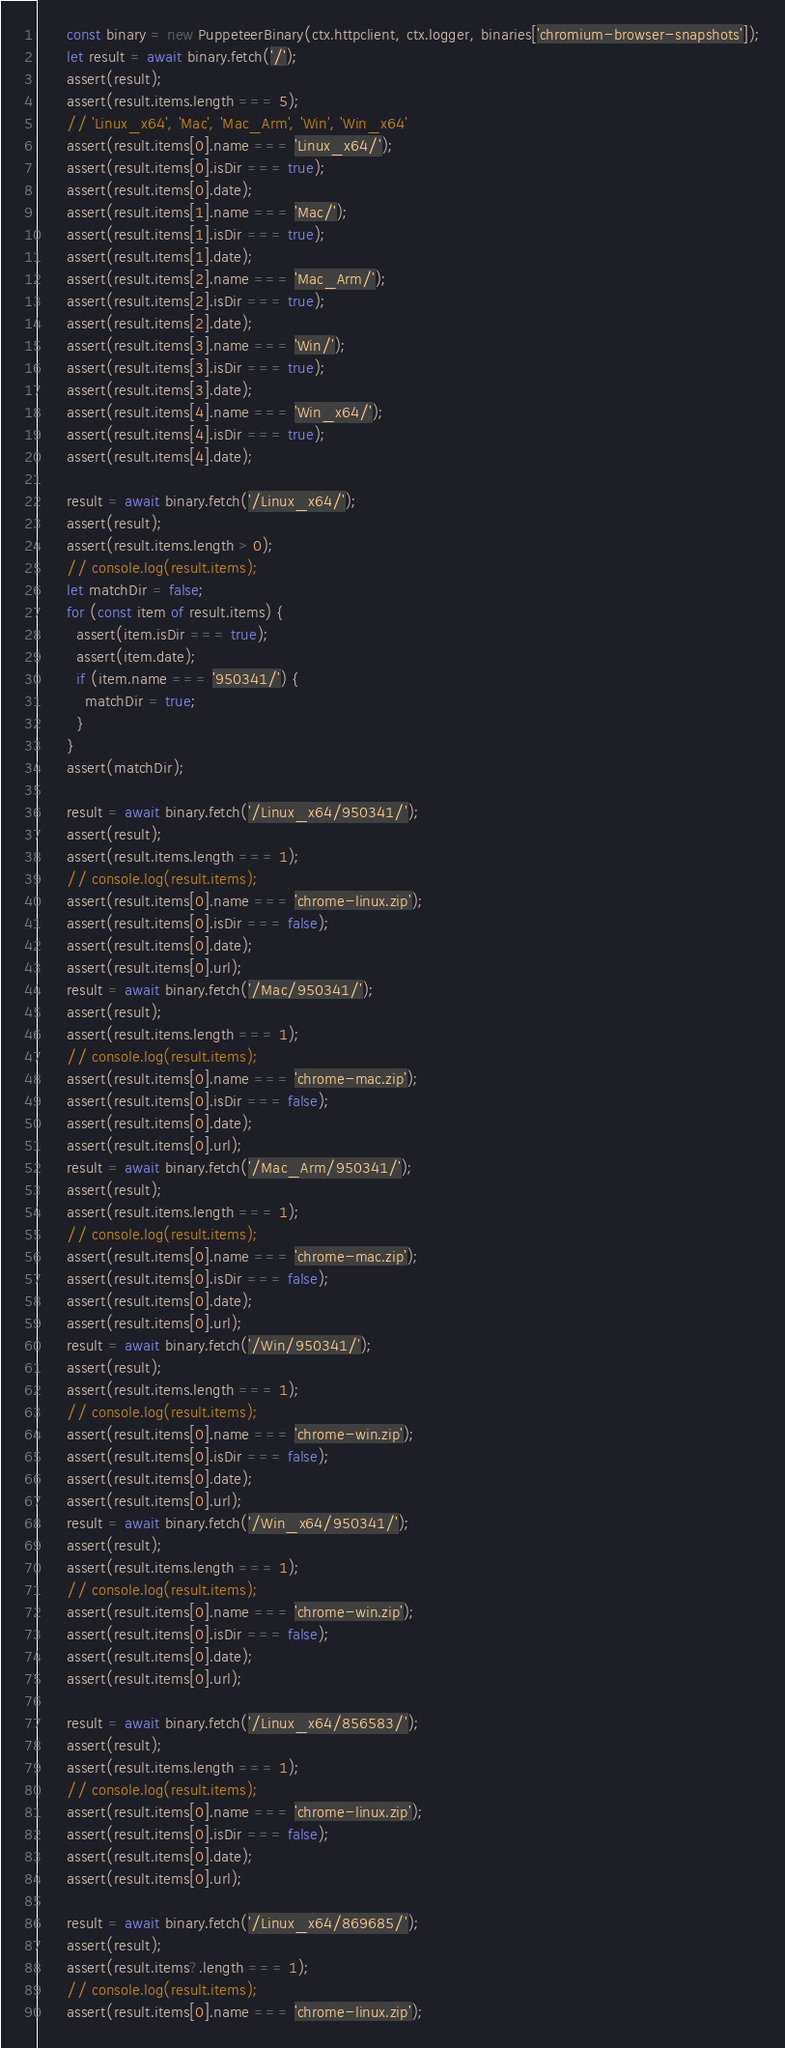Convert code to text. <code><loc_0><loc_0><loc_500><loc_500><_TypeScript_>      const binary = new PuppeteerBinary(ctx.httpclient, ctx.logger, binaries['chromium-browser-snapshots']);
      let result = await binary.fetch('/');
      assert(result);
      assert(result.items.length === 5);
      // 'Linux_x64', 'Mac', 'Mac_Arm', 'Win', 'Win_x64'
      assert(result.items[0].name === 'Linux_x64/');
      assert(result.items[0].isDir === true);
      assert(result.items[0].date);
      assert(result.items[1].name === 'Mac/');
      assert(result.items[1].isDir === true);
      assert(result.items[1].date);
      assert(result.items[2].name === 'Mac_Arm/');
      assert(result.items[2].isDir === true);
      assert(result.items[2].date);
      assert(result.items[3].name === 'Win/');
      assert(result.items[3].isDir === true);
      assert(result.items[3].date);
      assert(result.items[4].name === 'Win_x64/');
      assert(result.items[4].isDir === true);
      assert(result.items[4].date);

      result = await binary.fetch('/Linux_x64/');
      assert(result);
      assert(result.items.length > 0);
      // console.log(result.items);
      let matchDir = false;
      for (const item of result.items) {
        assert(item.isDir === true);
        assert(item.date);
        if (item.name === '950341/') {
          matchDir = true;
        }
      }
      assert(matchDir);

      result = await binary.fetch('/Linux_x64/950341/');
      assert(result);
      assert(result.items.length === 1);
      // console.log(result.items);
      assert(result.items[0].name === 'chrome-linux.zip');
      assert(result.items[0].isDir === false);
      assert(result.items[0].date);
      assert(result.items[0].url);
      result = await binary.fetch('/Mac/950341/');
      assert(result);
      assert(result.items.length === 1);
      // console.log(result.items);
      assert(result.items[0].name === 'chrome-mac.zip');
      assert(result.items[0].isDir === false);
      assert(result.items[0].date);
      assert(result.items[0].url);
      result = await binary.fetch('/Mac_Arm/950341/');
      assert(result);
      assert(result.items.length === 1);
      // console.log(result.items);
      assert(result.items[0].name === 'chrome-mac.zip');
      assert(result.items[0].isDir === false);
      assert(result.items[0].date);
      assert(result.items[0].url);
      result = await binary.fetch('/Win/950341/');
      assert(result);
      assert(result.items.length === 1);
      // console.log(result.items);
      assert(result.items[0].name === 'chrome-win.zip');
      assert(result.items[0].isDir === false);
      assert(result.items[0].date);
      assert(result.items[0].url);
      result = await binary.fetch('/Win_x64/950341/');
      assert(result);
      assert(result.items.length === 1);
      // console.log(result.items);
      assert(result.items[0].name === 'chrome-win.zip');
      assert(result.items[0].isDir === false);
      assert(result.items[0].date);
      assert(result.items[0].url);

      result = await binary.fetch('/Linux_x64/856583/');
      assert(result);
      assert(result.items.length === 1);
      // console.log(result.items);
      assert(result.items[0].name === 'chrome-linux.zip');
      assert(result.items[0].isDir === false);
      assert(result.items[0].date);
      assert(result.items[0].url);

      result = await binary.fetch('/Linux_x64/869685/');
      assert(result);
      assert(result.items?.length === 1);
      // console.log(result.items);
      assert(result.items[0].name === 'chrome-linux.zip');</code> 